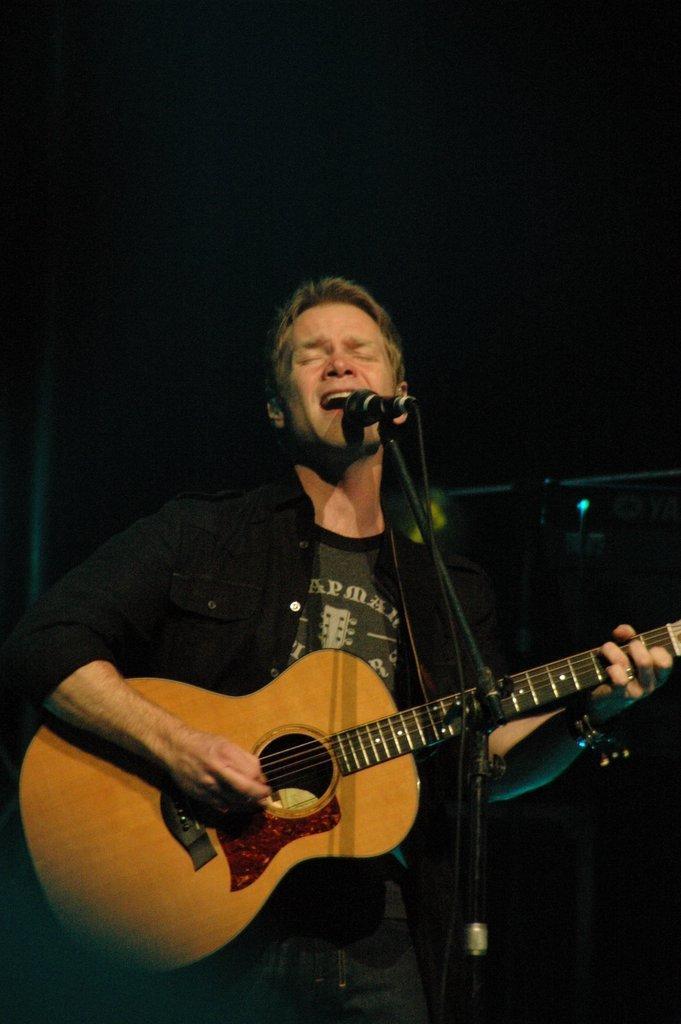Could you give a brief overview of what you see in this image? In this image there is a man playing a guitar and singing on a mike. He is wearing a black shirt and black jeans. The background is dark. 